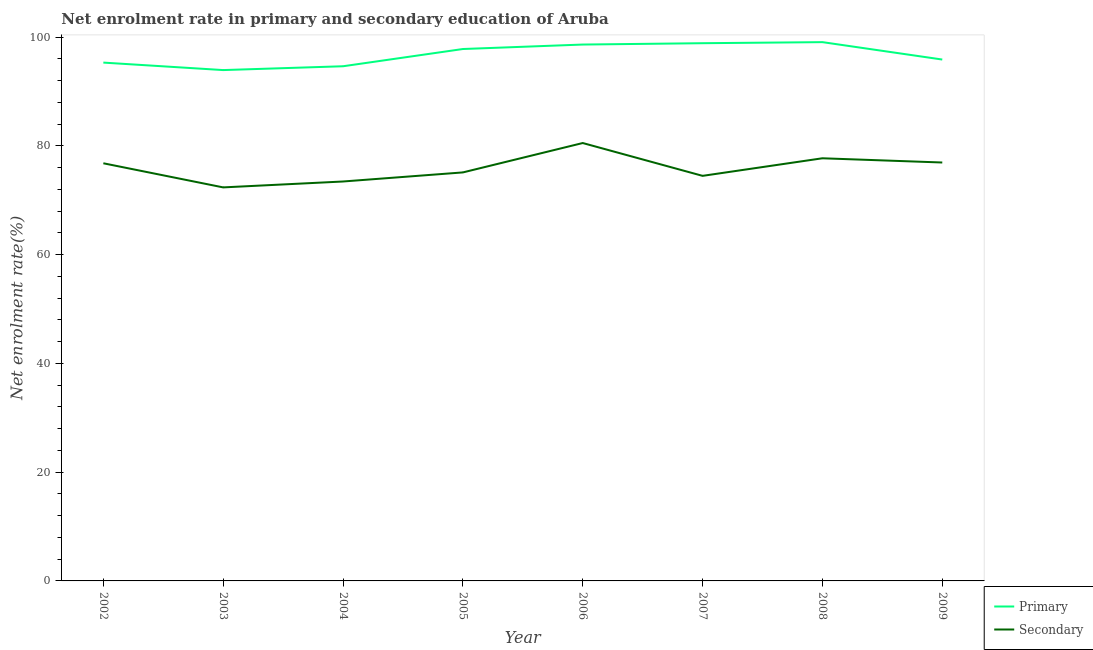What is the enrollment rate in secondary education in 2005?
Offer a terse response. 75.11. Across all years, what is the maximum enrollment rate in secondary education?
Your response must be concise. 80.52. Across all years, what is the minimum enrollment rate in primary education?
Your answer should be compact. 93.93. In which year was the enrollment rate in primary education maximum?
Give a very brief answer. 2008. In which year was the enrollment rate in secondary education minimum?
Offer a very short reply. 2003. What is the total enrollment rate in primary education in the graph?
Give a very brief answer. 774.12. What is the difference between the enrollment rate in secondary education in 2002 and that in 2005?
Make the answer very short. 1.68. What is the difference between the enrollment rate in secondary education in 2004 and the enrollment rate in primary education in 2002?
Your answer should be very brief. -21.86. What is the average enrollment rate in secondary education per year?
Offer a very short reply. 75.92. In the year 2006, what is the difference between the enrollment rate in primary education and enrollment rate in secondary education?
Ensure brevity in your answer.  18.11. What is the ratio of the enrollment rate in secondary education in 2005 to that in 2009?
Your response must be concise. 0.98. Is the difference between the enrollment rate in primary education in 2008 and 2009 greater than the difference between the enrollment rate in secondary education in 2008 and 2009?
Your answer should be very brief. Yes. What is the difference between the highest and the second highest enrollment rate in secondary education?
Provide a succinct answer. 2.8. What is the difference between the highest and the lowest enrollment rate in secondary education?
Ensure brevity in your answer.  8.16. Is the enrollment rate in primary education strictly greater than the enrollment rate in secondary education over the years?
Ensure brevity in your answer.  Yes. Is the enrollment rate in secondary education strictly less than the enrollment rate in primary education over the years?
Offer a very short reply. Yes. How many years are there in the graph?
Provide a short and direct response. 8. How many legend labels are there?
Your answer should be very brief. 2. What is the title of the graph?
Offer a very short reply. Net enrolment rate in primary and secondary education of Aruba. Does "Quasi money growth" appear as one of the legend labels in the graph?
Make the answer very short. No. What is the label or title of the Y-axis?
Keep it short and to the point. Net enrolment rate(%). What is the Net enrolment rate(%) in Primary in 2002?
Your answer should be compact. 95.31. What is the Net enrolment rate(%) of Secondary in 2002?
Offer a terse response. 76.8. What is the Net enrolment rate(%) in Primary in 2003?
Your response must be concise. 93.93. What is the Net enrolment rate(%) of Secondary in 2003?
Your answer should be very brief. 72.36. What is the Net enrolment rate(%) of Primary in 2004?
Your response must be concise. 94.63. What is the Net enrolment rate(%) of Secondary in 2004?
Provide a short and direct response. 73.44. What is the Net enrolment rate(%) of Primary in 2005?
Your answer should be compact. 97.81. What is the Net enrolment rate(%) of Secondary in 2005?
Offer a very short reply. 75.11. What is the Net enrolment rate(%) of Primary in 2006?
Offer a terse response. 98.63. What is the Net enrolment rate(%) in Secondary in 2006?
Give a very brief answer. 80.52. What is the Net enrolment rate(%) of Primary in 2007?
Give a very brief answer. 98.87. What is the Net enrolment rate(%) in Secondary in 2007?
Offer a very short reply. 74.48. What is the Net enrolment rate(%) of Primary in 2008?
Your answer should be compact. 99.07. What is the Net enrolment rate(%) in Secondary in 2008?
Your answer should be compact. 77.71. What is the Net enrolment rate(%) of Primary in 2009?
Provide a short and direct response. 95.87. What is the Net enrolment rate(%) of Secondary in 2009?
Make the answer very short. 76.94. Across all years, what is the maximum Net enrolment rate(%) of Primary?
Offer a very short reply. 99.07. Across all years, what is the maximum Net enrolment rate(%) of Secondary?
Your response must be concise. 80.52. Across all years, what is the minimum Net enrolment rate(%) in Primary?
Provide a short and direct response. 93.93. Across all years, what is the minimum Net enrolment rate(%) of Secondary?
Offer a terse response. 72.36. What is the total Net enrolment rate(%) of Primary in the graph?
Provide a succinct answer. 774.12. What is the total Net enrolment rate(%) of Secondary in the graph?
Provide a short and direct response. 607.37. What is the difference between the Net enrolment rate(%) of Primary in 2002 and that in 2003?
Provide a succinct answer. 1.38. What is the difference between the Net enrolment rate(%) of Secondary in 2002 and that in 2003?
Ensure brevity in your answer.  4.44. What is the difference between the Net enrolment rate(%) in Primary in 2002 and that in 2004?
Offer a very short reply. 0.67. What is the difference between the Net enrolment rate(%) in Secondary in 2002 and that in 2004?
Provide a short and direct response. 3.35. What is the difference between the Net enrolment rate(%) in Primary in 2002 and that in 2005?
Make the answer very short. -2.5. What is the difference between the Net enrolment rate(%) in Secondary in 2002 and that in 2005?
Your answer should be compact. 1.68. What is the difference between the Net enrolment rate(%) of Primary in 2002 and that in 2006?
Make the answer very short. -3.32. What is the difference between the Net enrolment rate(%) in Secondary in 2002 and that in 2006?
Make the answer very short. -3.72. What is the difference between the Net enrolment rate(%) in Primary in 2002 and that in 2007?
Make the answer very short. -3.57. What is the difference between the Net enrolment rate(%) in Secondary in 2002 and that in 2007?
Provide a succinct answer. 2.31. What is the difference between the Net enrolment rate(%) of Primary in 2002 and that in 2008?
Your answer should be compact. -3.76. What is the difference between the Net enrolment rate(%) of Secondary in 2002 and that in 2008?
Ensure brevity in your answer.  -0.92. What is the difference between the Net enrolment rate(%) in Primary in 2002 and that in 2009?
Offer a very short reply. -0.56. What is the difference between the Net enrolment rate(%) of Secondary in 2002 and that in 2009?
Keep it short and to the point. -0.14. What is the difference between the Net enrolment rate(%) of Primary in 2003 and that in 2004?
Your answer should be very brief. -0.7. What is the difference between the Net enrolment rate(%) of Secondary in 2003 and that in 2004?
Give a very brief answer. -1.08. What is the difference between the Net enrolment rate(%) in Primary in 2003 and that in 2005?
Give a very brief answer. -3.87. What is the difference between the Net enrolment rate(%) of Secondary in 2003 and that in 2005?
Make the answer very short. -2.75. What is the difference between the Net enrolment rate(%) of Primary in 2003 and that in 2006?
Your response must be concise. -4.7. What is the difference between the Net enrolment rate(%) in Secondary in 2003 and that in 2006?
Your answer should be compact. -8.16. What is the difference between the Net enrolment rate(%) in Primary in 2003 and that in 2007?
Make the answer very short. -4.94. What is the difference between the Net enrolment rate(%) in Secondary in 2003 and that in 2007?
Provide a short and direct response. -2.12. What is the difference between the Net enrolment rate(%) of Primary in 2003 and that in 2008?
Keep it short and to the point. -5.14. What is the difference between the Net enrolment rate(%) of Secondary in 2003 and that in 2008?
Your response must be concise. -5.35. What is the difference between the Net enrolment rate(%) of Primary in 2003 and that in 2009?
Ensure brevity in your answer.  -1.94. What is the difference between the Net enrolment rate(%) of Secondary in 2003 and that in 2009?
Your answer should be very brief. -4.58. What is the difference between the Net enrolment rate(%) in Primary in 2004 and that in 2005?
Ensure brevity in your answer.  -3.17. What is the difference between the Net enrolment rate(%) in Secondary in 2004 and that in 2005?
Ensure brevity in your answer.  -1.67. What is the difference between the Net enrolment rate(%) in Primary in 2004 and that in 2006?
Provide a succinct answer. -3.99. What is the difference between the Net enrolment rate(%) in Secondary in 2004 and that in 2006?
Your response must be concise. -7.07. What is the difference between the Net enrolment rate(%) in Primary in 2004 and that in 2007?
Ensure brevity in your answer.  -4.24. What is the difference between the Net enrolment rate(%) of Secondary in 2004 and that in 2007?
Your answer should be compact. -1.04. What is the difference between the Net enrolment rate(%) in Primary in 2004 and that in 2008?
Keep it short and to the point. -4.43. What is the difference between the Net enrolment rate(%) of Secondary in 2004 and that in 2008?
Offer a terse response. -4.27. What is the difference between the Net enrolment rate(%) of Primary in 2004 and that in 2009?
Offer a very short reply. -1.23. What is the difference between the Net enrolment rate(%) of Secondary in 2004 and that in 2009?
Offer a very short reply. -3.49. What is the difference between the Net enrolment rate(%) in Primary in 2005 and that in 2006?
Keep it short and to the point. -0.82. What is the difference between the Net enrolment rate(%) in Secondary in 2005 and that in 2006?
Give a very brief answer. -5.4. What is the difference between the Net enrolment rate(%) in Primary in 2005 and that in 2007?
Your answer should be very brief. -1.07. What is the difference between the Net enrolment rate(%) of Secondary in 2005 and that in 2007?
Your answer should be compact. 0.63. What is the difference between the Net enrolment rate(%) in Primary in 2005 and that in 2008?
Ensure brevity in your answer.  -1.26. What is the difference between the Net enrolment rate(%) of Secondary in 2005 and that in 2008?
Ensure brevity in your answer.  -2.6. What is the difference between the Net enrolment rate(%) in Primary in 2005 and that in 2009?
Keep it short and to the point. 1.94. What is the difference between the Net enrolment rate(%) in Secondary in 2005 and that in 2009?
Give a very brief answer. -1.82. What is the difference between the Net enrolment rate(%) of Primary in 2006 and that in 2007?
Offer a very short reply. -0.24. What is the difference between the Net enrolment rate(%) of Secondary in 2006 and that in 2007?
Make the answer very short. 6.03. What is the difference between the Net enrolment rate(%) in Primary in 2006 and that in 2008?
Make the answer very short. -0.44. What is the difference between the Net enrolment rate(%) in Secondary in 2006 and that in 2008?
Your answer should be compact. 2.8. What is the difference between the Net enrolment rate(%) of Primary in 2006 and that in 2009?
Offer a very short reply. 2.76. What is the difference between the Net enrolment rate(%) in Secondary in 2006 and that in 2009?
Provide a succinct answer. 3.58. What is the difference between the Net enrolment rate(%) in Primary in 2007 and that in 2008?
Your answer should be compact. -0.2. What is the difference between the Net enrolment rate(%) in Secondary in 2007 and that in 2008?
Offer a terse response. -3.23. What is the difference between the Net enrolment rate(%) in Primary in 2007 and that in 2009?
Give a very brief answer. 3. What is the difference between the Net enrolment rate(%) of Secondary in 2007 and that in 2009?
Your answer should be very brief. -2.45. What is the difference between the Net enrolment rate(%) of Primary in 2008 and that in 2009?
Offer a terse response. 3.2. What is the difference between the Net enrolment rate(%) in Secondary in 2008 and that in 2009?
Provide a succinct answer. 0.78. What is the difference between the Net enrolment rate(%) of Primary in 2002 and the Net enrolment rate(%) of Secondary in 2003?
Give a very brief answer. 22.95. What is the difference between the Net enrolment rate(%) of Primary in 2002 and the Net enrolment rate(%) of Secondary in 2004?
Keep it short and to the point. 21.86. What is the difference between the Net enrolment rate(%) of Primary in 2002 and the Net enrolment rate(%) of Secondary in 2005?
Your answer should be very brief. 20.19. What is the difference between the Net enrolment rate(%) in Primary in 2002 and the Net enrolment rate(%) in Secondary in 2006?
Provide a succinct answer. 14.79. What is the difference between the Net enrolment rate(%) in Primary in 2002 and the Net enrolment rate(%) in Secondary in 2007?
Offer a very short reply. 20.82. What is the difference between the Net enrolment rate(%) of Primary in 2002 and the Net enrolment rate(%) of Secondary in 2008?
Give a very brief answer. 17.59. What is the difference between the Net enrolment rate(%) in Primary in 2002 and the Net enrolment rate(%) in Secondary in 2009?
Your answer should be compact. 18.37. What is the difference between the Net enrolment rate(%) of Primary in 2003 and the Net enrolment rate(%) of Secondary in 2004?
Your response must be concise. 20.49. What is the difference between the Net enrolment rate(%) of Primary in 2003 and the Net enrolment rate(%) of Secondary in 2005?
Make the answer very short. 18.82. What is the difference between the Net enrolment rate(%) in Primary in 2003 and the Net enrolment rate(%) in Secondary in 2006?
Offer a very short reply. 13.41. What is the difference between the Net enrolment rate(%) in Primary in 2003 and the Net enrolment rate(%) in Secondary in 2007?
Give a very brief answer. 19.45. What is the difference between the Net enrolment rate(%) in Primary in 2003 and the Net enrolment rate(%) in Secondary in 2008?
Offer a terse response. 16.22. What is the difference between the Net enrolment rate(%) of Primary in 2003 and the Net enrolment rate(%) of Secondary in 2009?
Ensure brevity in your answer.  16.99. What is the difference between the Net enrolment rate(%) of Primary in 2004 and the Net enrolment rate(%) of Secondary in 2005?
Make the answer very short. 19.52. What is the difference between the Net enrolment rate(%) in Primary in 2004 and the Net enrolment rate(%) in Secondary in 2006?
Your answer should be compact. 14.12. What is the difference between the Net enrolment rate(%) of Primary in 2004 and the Net enrolment rate(%) of Secondary in 2007?
Your answer should be compact. 20.15. What is the difference between the Net enrolment rate(%) of Primary in 2004 and the Net enrolment rate(%) of Secondary in 2008?
Give a very brief answer. 16.92. What is the difference between the Net enrolment rate(%) of Primary in 2004 and the Net enrolment rate(%) of Secondary in 2009?
Your response must be concise. 17.7. What is the difference between the Net enrolment rate(%) of Primary in 2005 and the Net enrolment rate(%) of Secondary in 2006?
Keep it short and to the point. 17.29. What is the difference between the Net enrolment rate(%) of Primary in 2005 and the Net enrolment rate(%) of Secondary in 2007?
Your answer should be compact. 23.32. What is the difference between the Net enrolment rate(%) of Primary in 2005 and the Net enrolment rate(%) of Secondary in 2008?
Keep it short and to the point. 20.09. What is the difference between the Net enrolment rate(%) of Primary in 2005 and the Net enrolment rate(%) of Secondary in 2009?
Your response must be concise. 20.87. What is the difference between the Net enrolment rate(%) in Primary in 2006 and the Net enrolment rate(%) in Secondary in 2007?
Your answer should be compact. 24.15. What is the difference between the Net enrolment rate(%) in Primary in 2006 and the Net enrolment rate(%) in Secondary in 2008?
Your answer should be compact. 20.91. What is the difference between the Net enrolment rate(%) in Primary in 2006 and the Net enrolment rate(%) in Secondary in 2009?
Your answer should be very brief. 21.69. What is the difference between the Net enrolment rate(%) in Primary in 2007 and the Net enrolment rate(%) in Secondary in 2008?
Make the answer very short. 21.16. What is the difference between the Net enrolment rate(%) in Primary in 2007 and the Net enrolment rate(%) in Secondary in 2009?
Ensure brevity in your answer.  21.94. What is the difference between the Net enrolment rate(%) of Primary in 2008 and the Net enrolment rate(%) of Secondary in 2009?
Keep it short and to the point. 22.13. What is the average Net enrolment rate(%) in Primary per year?
Make the answer very short. 96.76. What is the average Net enrolment rate(%) of Secondary per year?
Your answer should be very brief. 75.92. In the year 2002, what is the difference between the Net enrolment rate(%) of Primary and Net enrolment rate(%) of Secondary?
Provide a short and direct response. 18.51. In the year 2003, what is the difference between the Net enrolment rate(%) in Primary and Net enrolment rate(%) in Secondary?
Offer a very short reply. 21.57. In the year 2004, what is the difference between the Net enrolment rate(%) in Primary and Net enrolment rate(%) in Secondary?
Keep it short and to the point. 21.19. In the year 2005, what is the difference between the Net enrolment rate(%) in Primary and Net enrolment rate(%) in Secondary?
Your answer should be very brief. 22.69. In the year 2006, what is the difference between the Net enrolment rate(%) of Primary and Net enrolment rate(%) of Secondary?
Ensure brevity in your answer.  18.11. In the year 2007, what is the difference between the Net enrolment rate(%) of Primary and Net enrolment rate(%) of Secondary?
Your answer should be compact. 24.39. In the year 2008, what is the difference between the Net enrolment rate(%) of Primary and Net enrolment rate(%) of Secondary?
Offer a terse response. 21.36. In the year 2009, what is the difference between the Net enrolment rate(%) in Primary and Net enrolment rate(%) in Secondary?
Ensure brevity in your answer.  18.93. What is the ratio of the Net enrolment rate(%) of Primary in 2002 to that in 2003?
Your answer should be very brief. 1.01. What is the ratio of the Net enrolment rate(%) of Secondary in 2002 to that in 2003?
Give a very brief answer. 1.06. What is the ratio of the Net enrolment rate(%) of Primary in 2002 to that in 2004?
Your answer should be very brief. 1.01. What is the ratio of the Net enrolment rate(%) in Secondary in 2002 to that in 2004?
Give a very brief answer. 1.05. What is the ratio of the Net enrolment rate(%) in Primary in 2002 to that in 2005?
Your answer should be very brief. 0.97. What is the ratio of the Net enrolment rate(%) in Secondary in 2002 to that in 2005?
Keep it short and to the point. 1.02. What is the ratio of the Net enrolment rate(%) in Primary in 2002 to that in 2006?
Provide a short and direct response. 0.97. What is the ratio of the Net enrolment rate(%) in Secondary in 2002 to that in 2006?
Provide a short and direct response. 0.95. What is the ratio of the Net enrolment rate(%) of Primary in 2002 to that in 2007?
Keep it short and to the point. 0.96. What is the ratio of the Net enrolment rate(%) in Secondary in 2002 to that in 2007?
Provide a succinct answer. 1.03. What is the ratio of the Net enrolment rate(%) in Primary in 2002 to that in 2008?
Offer a very short reply. 0.96. What is the ratio of the Net enrolment rate(%) in Secondary in 2002 to that in 2009?
Offer a very short reply. 1. What is the ratio of the Net enrolment rate(%) in Primary in 2003 to that in 2004?
Ensure brevity in your answer.  0.99. What is the ratio of the Net enrolment rate(%) of Secondary in 2003 to that in 2004?
Make the answer very short. 0.99. What is the ratio of the Net enrolment rate(%) in Primary in 2003 to that in 2005?
Make the answer very short. 0.96. What is the ratio of the Net enrolment rate(%) in Secondary in 2003 to that in 2005?
Provide a short and direct response. 0.96. What is the ratio of the Net enrolment rate(%) of Primary in 2003 to that in 2006?
Your answer should be compact. 0.95. What is the ratio of the Net enrolment rate(%) of Secondary in 2003 to that in 2006?
Keep it short and to the point. 0.9. What is the ratio of the Net enrolment rate(%) of Primary in 2003 to that in 2007?
Make the answer very short. 0.95. What is the ratio of the Net enrolment rate(%) of Secondary in 2003 to that in 2007?
Your response must be concise. 0.97. What is the ratio of the Net enrolment rate(%) of Primary in 2003 to that in 2008?
Give a very brief answer. 0.95. What is the ratio of the Net enrolment rate(%) in Secondary in 2003 to that in 2008?
Offer a terse response. 0.93. What is the ratio of the Net enrolment rate(%) of Primary in 2003 to that in 2009?
Your answer should be very brief. 0.98. What is the ratio of the Net enrolment rate(%) of Secondary in 2003 to that in 2009?
Make the answer very short. 0.94. What is the ratio of the Net enrolment rate(%) of Primary in 2004 to that in 2005?
Your answer should be compact. 0.97. What is the ratio of the Net enrolment rate(%) of Secondary in 2004 to that in 2005?
Offer a terse response. 0.98. What is the ratio of the Net enrolment rate(%) in Primary in 2004 to that in 2006?
Offer a very short reply. 0.96. What is the ratio of the Net enrolment rate(%) in Secondary in 2004 to that in 2006?
Provide a succinct answer. 0.91. What is the ratio of the Net enrolment rate(%) of Primary in 2004 to that in 2007?
Keep it short and to the point. 0.96. What is the ratio of the Net enrolment rate(%) of Secondary in 2004 to that in 2007?
Offer a very short reply. 0.99. What is the ratio of the Net enrolment rate(%) in Primary in 2004 to that in 2008?
Offer a terse response. 0.96. What is the ratio of the Net enrolment rate(%) of Secondary in 2004 to that in 2008?
Your answer should be very brief. 0.95. What is the ratio of the Net enrolment rate(%) of Primary in 2004 to that in 2009?
Offer a terse response. 0.99. What is the ratio of the Net enrolment rate(%) in Secondary in 2004 to that in 2009?
Keep it short and to the point. 0.95. What is the ratio of the Net enrolment rate(%) in Secondary in 2005 to that in 2006?
Your response must be concise. 0.93. What is the ratio of the Net enrolment rate(%) of Primary in 2005 to that in 2007?
Make the answer very short. 0.99. What is the ratio of the Net enrolment rate(%) of Secondary in 2005 to that in 2007?
Ensure brevity in your answer.  1.01. What is the ratio of the Net enrolment rate(%) in Primary in 2005 to that in 2008?
Make the answer very short. 0.99. What is the ratio of the Net enrolment rate(%) of Secondary in 2005 to that in 2008?
Give a very brief answer. 0.97. What is the ratio of the Net enrolment rate(%) of Primary in 2005 to that in 2009?
Your response must be concise. 1.02. What is the ratio of the Net enrolment rate(%) in Secondary in 2005 to that in 2009?
Your answer should be very brief. 0.98. What is the ratio of the Net enrolment rate(%) of Primary in 2006 to that in 2007?
Make the answer very short. 1. What is the ratio of the Net enrolment rate(%) of Secondary in 2006 to that in 2007?
Your answer should be very brief. 1.08. What is the ratio of the Net enrolment rate(%) of Primary in 2006 to that in 2008?
Your answer should be very brief. 1. What is the ratio of the Net enrolment rate(%) of Secondary in 2006 to that in 2008?
Make the answer very short. 1.04. What is the ratio of the Net enrolment rate(%) in Primary in 2006 to that in 2009?
Make the answer very short. 1.03. What is the ratio of the Net enrolment rate(%) in Secondary in 2006 to that in 2009?
Provide a succinct answer. 1.05. What is the ratio of the Net enrolment rate(%) of Primary in 2007 to that in 2008?
Your answer should be very brief. 1. What is the ratio of the Net enrolment rate(%) of Secondary in 2007 to that in 2008?
Keep it short and to the point. 0.96. What is the ratio of the Net enrolment rate(%) of Primary in 2007 to that in 2009?
Offer a very short reply. 1.03. What is the ratio of the Net enrolment rate(%) of Secondary in 2007 to that in 2009?
Your answer should be very brief. 0.97. What is the ratio of the Net enrolment rate(%) in Primary in 2008 to that in 2009?
Provide a succinct answer. 1.03. What is the ratio of the Net enrolment rate(%) in Secondary in 2008 to that in 2009?
Your response must be concise. 1.01. What is the difference between the highest and the second highest Net enrolment rate(%) in Primary?
Provide a short and direct response. 0.2. What is the difference between the highest and the second highest Net enrolment rate(%) in Secondary?
Provide a short and direct response. 2.8. What is the difference between the highest and the lowest Net enrolment rate(%) in Primary?
Keep it short and to the point. 5.14. What is the difference between the highest and the lowest Net enrolment rate(%) of Secondary?
Provide a short and direct response. 8.16. 